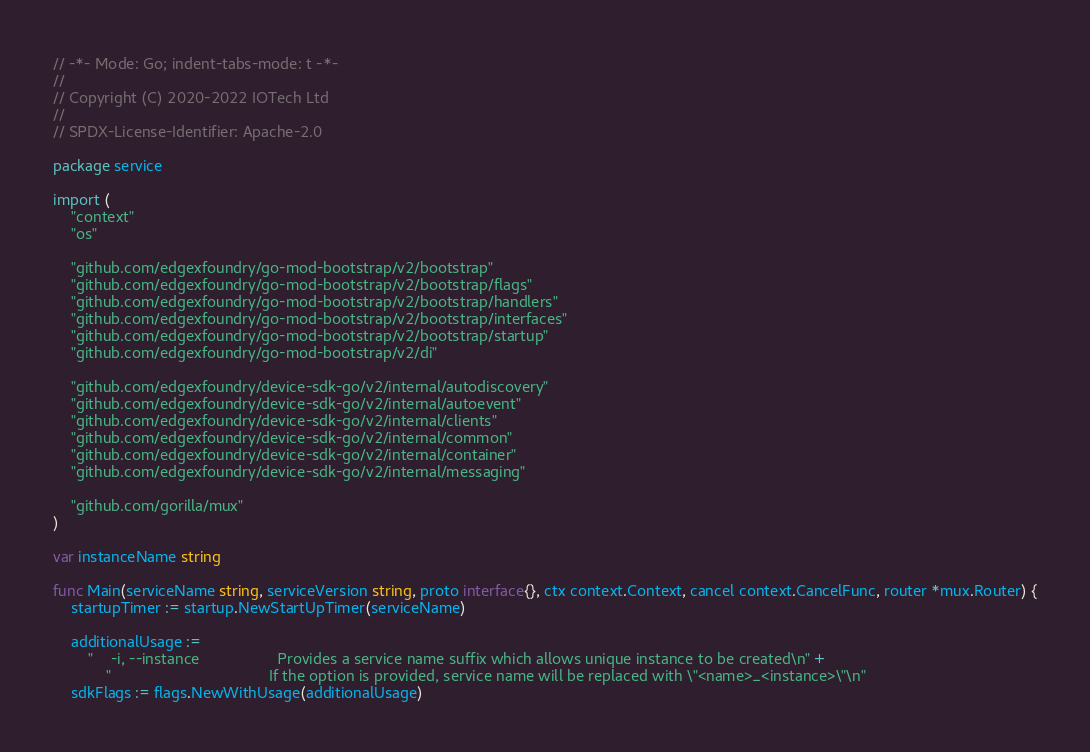<code> <loc_0><loc_0><loc_500><loc_500><_Go_>// -*- Mode: Go; indent-tabs-mode: t -*-
//
// Copyright (C) 2020-2022 IOTech Ltd
//
// SPDX-License-Identifier: Apache-2.0

package service

import (
	"context"
	"os"

	"github.com/edgexfoundry/go-mod-bootstrap/v2/bootstrap"
	"github.com/edgexfoundry/go-mod-bootstrap/v2/bootstrap/flags"
	"github.com/edgexfoundry/go-mod-bootstrap/v2/bootstrap/handlers"
	"github.com/edgexfoundry/go-mod-bootstrap/v2/bootstrap/interfaces"
	"github.com/edgexfoundry/go-mod-bootstrap/v2/bootstrap/startup"
	"github.com/edgexfoundry/go-mod-bootstrap/v2/di"

	"github.com/edgexfoundry/device-sdk-go/v2/internal/autodiscovery"
	"github.com/edgexfoundry/device-sdk-go/v2/internal/autoevent"
	"github.com/edgexfoundry/device-sdk-go/v2/internal/clients"
	"github.com/edgexfoundry/device-sdk-go/v2/internal/common"
	"github.com/edgexfoundry/device-sdk-go/v2/internal/container"
	"github.com/edgexfoundry/device-sdk-go/v2/internal/messaging"

	"github.com/gorilla/mux"
)

var instanceName string

func Main(serviceName string, serviceVersion string, proto interface{}, ctx context.Context, cancel context.CancelFunc, router *mux.Router) {
	startupTimer := startup.NewStartUpTimer(serviceName)

	additionalUsage :=
		"    -i, --instance                  Provides a service name suffix which allows unique instance to be created\n" +
			"                                    If the option is provided, service name will be replaced with \"<name>_<instance>\"\n"
	sdkFlags := flags.NewWithUsage(additionalUsage)</code> 